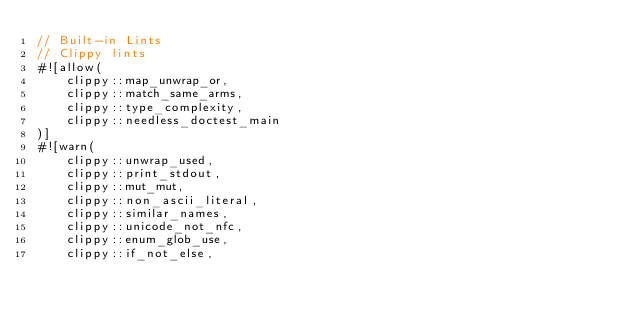<code> <loc_0><loc_0><loc_500><loc_500><_Rust_>// Built-in Lints
// Clippy lints
#![allow(
    clippy::map_unwrap_or,
    clippy::match_same_arms,
    clippy::type_complexity,
    clippy::needless_doctest_main
)]
#![warn(
    clippy::unwrap_used,
    clippy::print_stdout,
    clippy::mut_mut,
    clippy::non_ascii_literal,
    clippy::similar_names,
    clippy::unicode_not_nfc,
    clippy::enum_glob_use,
    clippy::if_not_else,</code> 